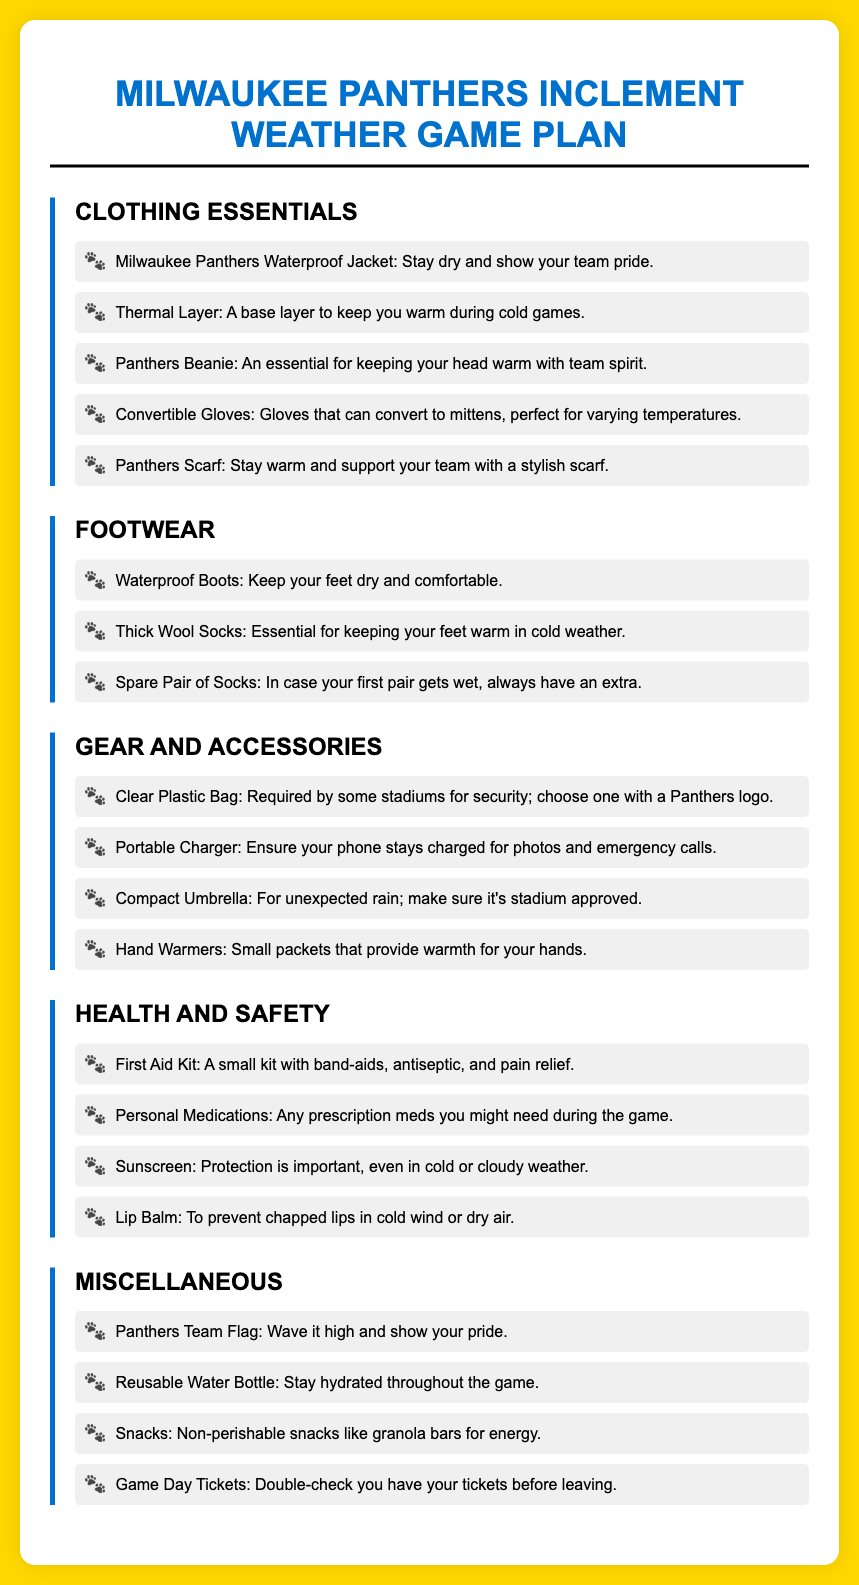What is the name of the waterproof jacket? The document lists "Milwaukee Panthers Waterproof Jacket" as an essential item under Clothing Essentials.
Answer: Milwaukee Panthers Waterproof Jacket What type of socks should be packed? There are two types of socks mentioned: "Thick Wool Socks" and "Spare Pair of Socks".
Answer: Thick Wool Socks What item is listed for hand warmth? The list under Gear and Accessories mentions "Hand Warmers" as a way to keep hands warm.
Answer: Hand Warmers How many clothing items are listed? There are five items mentioned under Clothing Essentials.
Answer: Five What should you double-check before leaving? The document reminds to check for "Game Day Tickets" before departing.
Answer: Game Day Tickets Which item is necessary for personal safety? The section on Health and Safety recommends packing a "First Aid Kit".
Answer: First Aid Kit What is the purpose of the clear plastic bag? It is noted as a requirement by some stadiums for security, emphasizing the importance of having one.
Answer: Required by some stadiums for security How can you stay hydrated during the game? The document suggests bringing a "Reusable Water Bottle" for hydration.
Answer: Reusable Water Bottle What clothing item provides team spirit while keeping your head warm? The document lists the "Panthers Beanie" as a clothing item that serves this purpose.
Answer: Panthers Beanie 